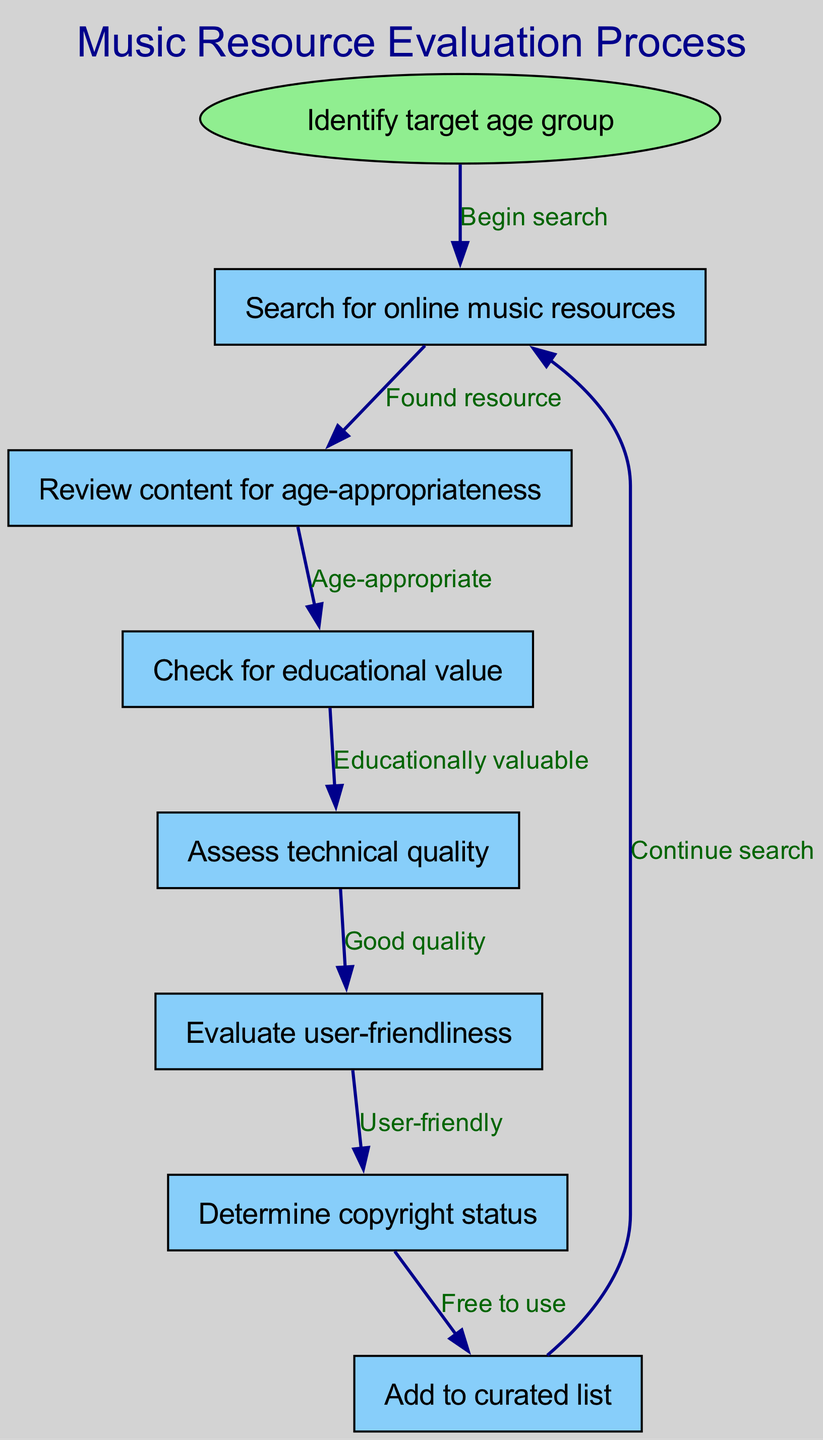What is the starting point of the process? The starting point of the process as indicated in the diagram is "Identify target age group". This is the initial action that leads to the evaluation of online music resources.
Answer: Identify target age group How many nodes are present in the diagram? The diagram contains a total of 7 nodes, which represent the various steps in the evaluation process.
Answer: 7 What is the final action in the flow chart? The final action in the flow chart is "Add to curated list", which signifies the completion of the evaluation process when a resource is deemed appropriate for inclusion.
Answer: Add to curated list Which node comes after "Assess technical quality"? After "Assess technical quality", the next node is "Evaluate user-friendliness". This indicates that user-friendliness is considered after technical quality.
Answer: Evaluate user-friendliness What must be true for a resource to be added to the curated list? For a resource to be added to the curated list, it must have passed through all the previous evaluations and ultimately be "Free to use". This indicates that all criteria must be met before inclusion.
Answer: Free to use Which node is the first step after the search for online music resources? The first step after searching for online music resources is "Review content for age-appropriateness". This shows that the evaluation begins with assessing if the content is suitable for the desired age group.
Answer: Review content for age-appropriateness What must be assessed before determining the copyright status? Before determining the copyright status, the node "Evaluate user-friendliness" must be examined. This indicates a sequential evaluation where user-friendliness is a prerequisite for assessing copyright.
Answer: Evaluate user-friendliness How does the flow restart after adding a resource to the curated list? After adding a resource to the curated list, the flow restarts with "Continue search", indicating that the process is cyclic and allows for the addition of multiple resources.
Answer: Continue search 